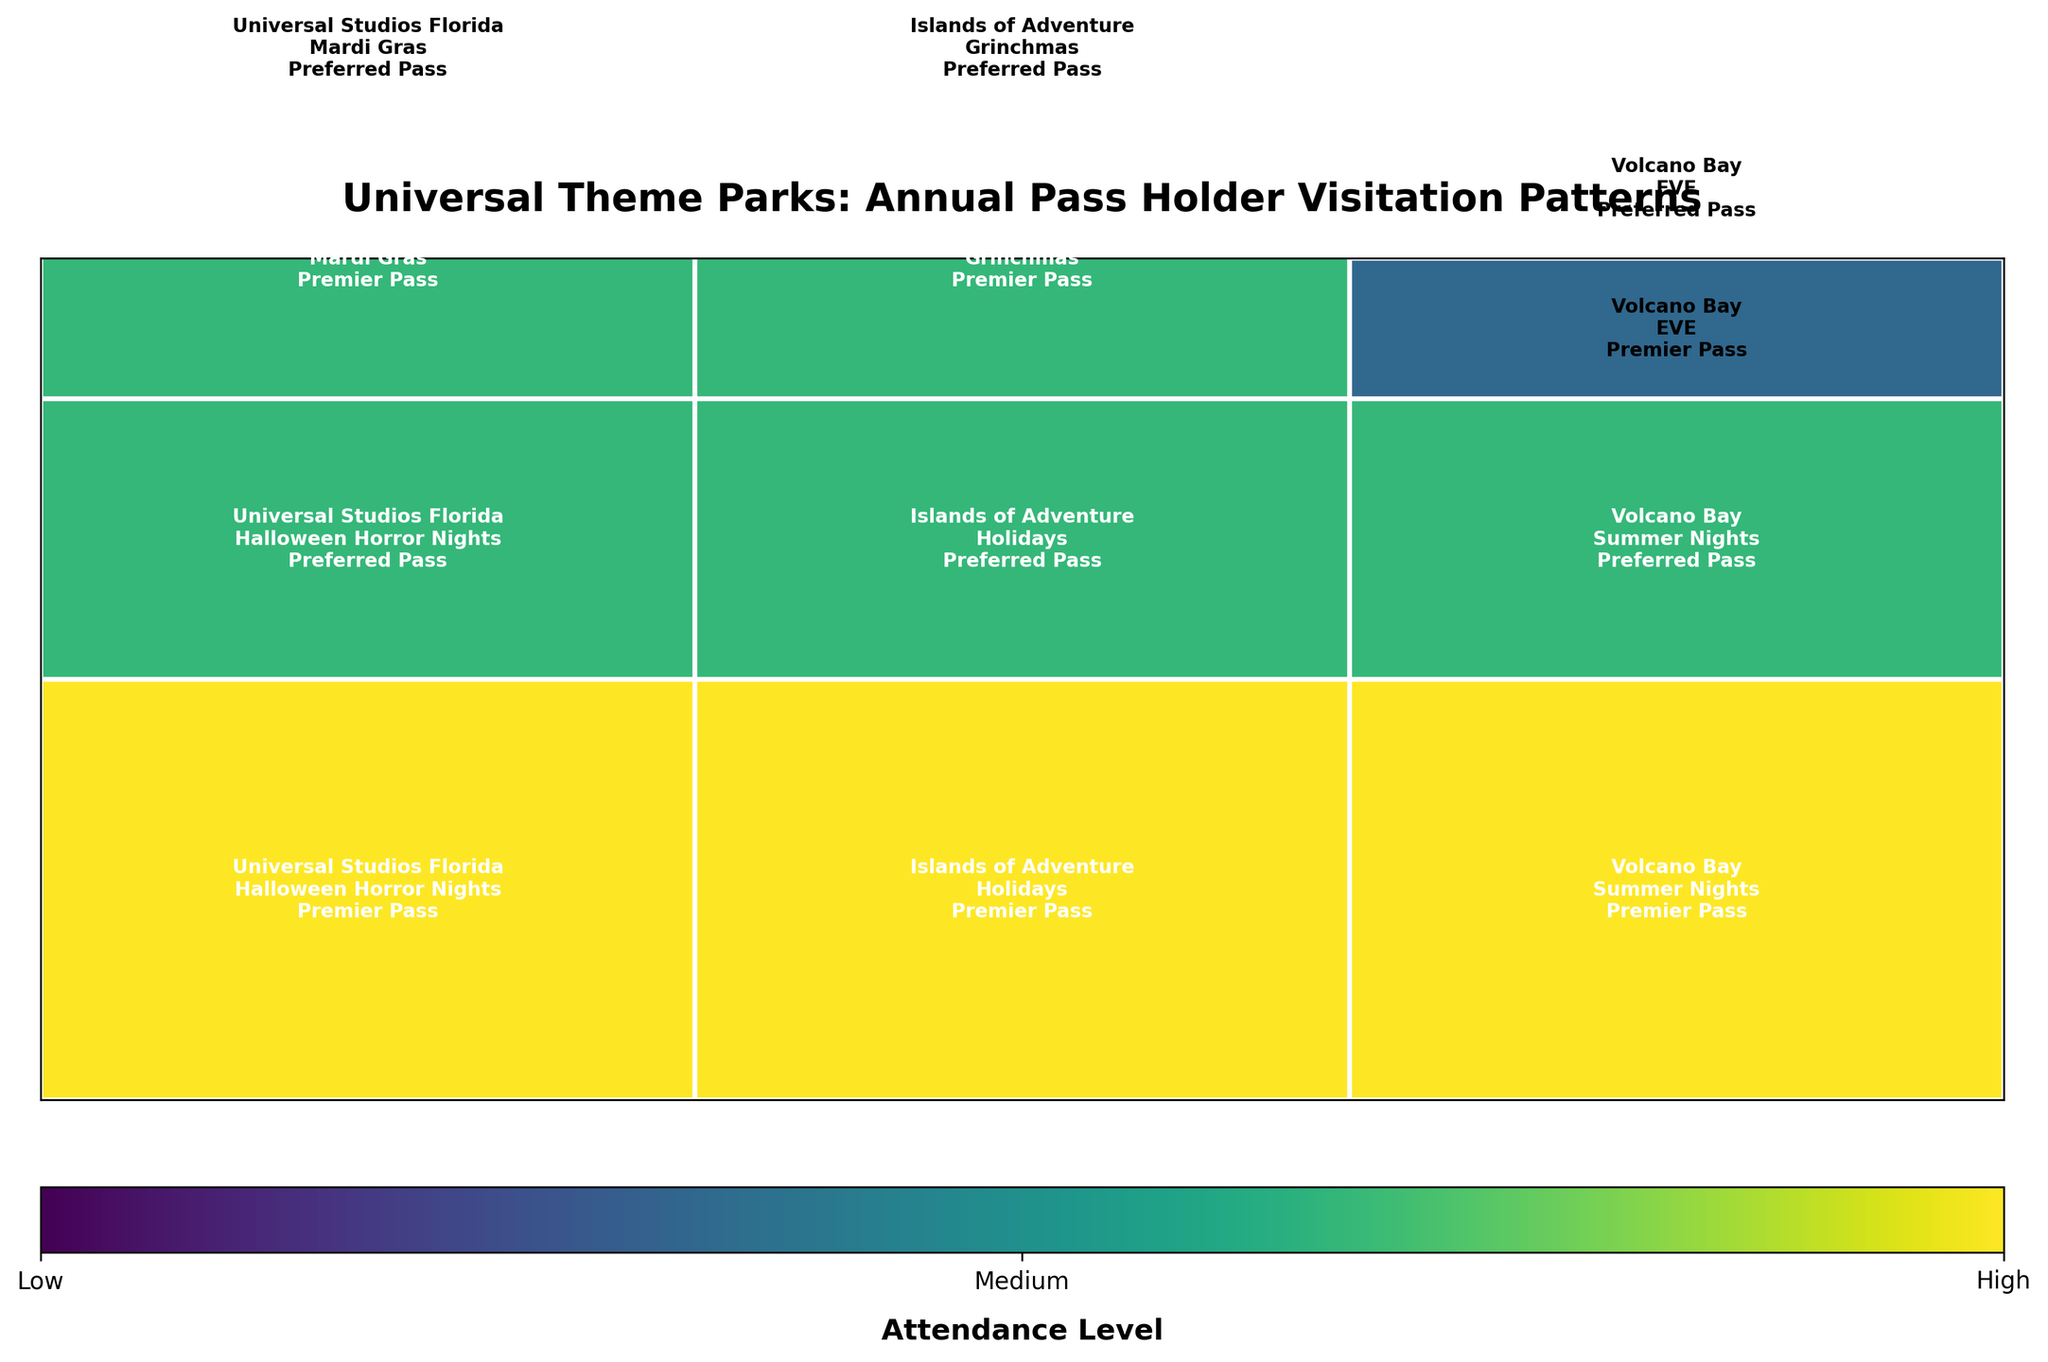What is the attendance level for Premier Pass holders at Halloween Horror Nights in Universal Studios Florida? The rectangular segment for Premier Pass holders at Halloween Horror Nights in Universal Studios Florida is filled with a color representing a 'High' attendance level on the vertical color bar (3).
Answer: High Which event at Volcano Bay has the lowest attendance for both Premier and Preferred Pass holders? Look for events at Volcano Bay with the lowest filling value in both color intensity and height. The event 'EVE' at Volcano Bay corresponds to a 'Low' attendance level for both pass types (height 1).
Answer: EVE How does the attendance at Islands of Adventure during Holidays compare between Premier and Preferred Pass holders? The attendance levels ('High' for Premier and 'Medium' for Preferred) can be compared by observing the respective parts of the bar for the Holidays event at Islands of Adventure.
Answer: Premier attendance is higher Which park-event combination has the same attendance level for both Premier and Preferred Pass holders? Check all the park-event combinations for equal heights and colors for both pass types. At Volcano Bay during 'EVE', both Premier and Preferred Pass holders have 'Low' attendance levels.
Answer: Volcano Bay, EVE In Universal Studios Florida, is the attendance for Mardi Gras higher for Premier or Preferred Pass holders? Compare the heights of the segments for Mardi Gras in Universal Studios Florida for both pass types. The height for Premier Pass holders (Medium, height 2) is higher than for Preferred Pass holders (Low, height 1).
Answer: Premier is higher Among the events at Islands of Adventure, which one has a higher attendance of Preferred Pass holders: Holidays or Grinchmas? Look at the heights of the segments for Preferred Pass holders in the Holidays and Grinchmas events. Holidays has a 'Medium' attendance level (height 2), whereas Grinchmas has a 'Low' level (height 1).
Answer: Holidays Count the number of events where Premier Pass holders have a 'High' attendance level. Identify segments with 'High' attendance levels (height 3) specific to Premier Pass holders. Premier Pass holders have 'High' attendance for Halloween Horror Nights at Universal Studios Florida, Holidays at Islands of Adventure, and Summer Nights at Volcano Bay, totaling 3 events.
Answer: 3 Which event at Universal Studios Florida has a lower attendance level for Preferred Pass holders, Halloween Horror Nights or Mardi Gras? Compare the heights of the segments for Preferred Pass holders in Halloween Horror Nights and Mardi Gras at Universal Studios Florida. Halloween Horror Nights is 'Medium' (height 2), and Mardi Gras is 'Low' (height 1).
Answer: Mardi Gras 